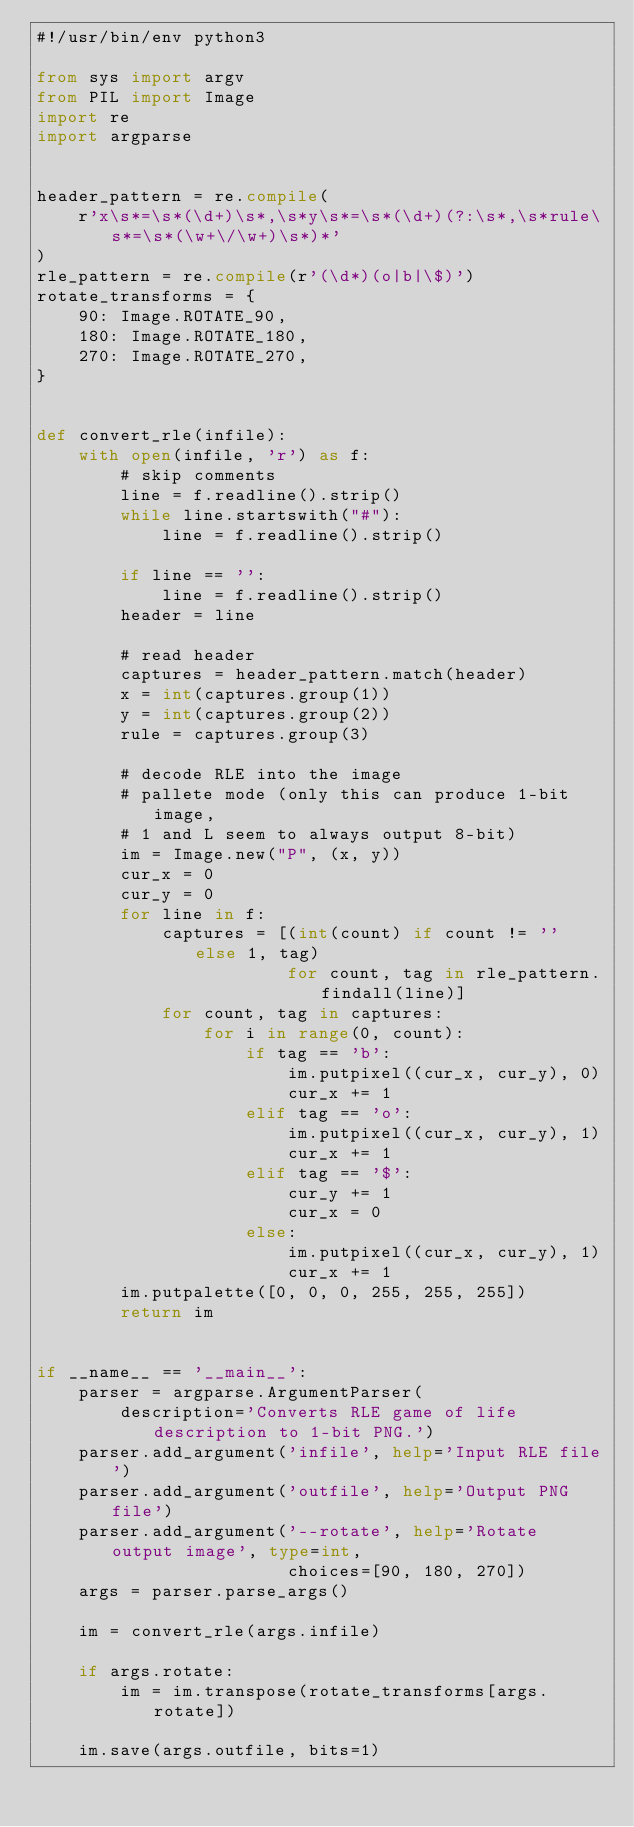<code> <loc_0><loc_0><loc_500><loc_500><_Python_>#!/usr/bin/env python3

from sys import argv
from PIL import Image
import re
import argparse


header_pattern = re.compile(
    r'x\s*=\s*(\d+)\s*,\s*y\s*=\s*(\d+)(?:\s*,\s*rule\s*=\s*(\w+\/\w+)\s*)*'
)
rle_pattern = re.compile(r'(\d*)(o|b|\$)')
rotate_transforms = {
    90: Image.ROTATE_90,
    180: Image.ROTATE_180,
    270: Image.ROTATE_270,
}


def convert_rle(infile):
    with open(infile, 'r') as f:
        # skip comments
        line = f.readline().strip()
        while line.startswith("#"):
            line = f.readline().strip()

        if line == '':
            line = f.readline().strip()
        header = line

        # read header
        captures = header_pattern.match(header)
        x = int(captures.group(1))
        y = int(captures.group(2))
        rule = captures.group(3)

        # decode RLE into the image
        # pallete mode (only this can produce 1-bit image,
        # 1 and L seem to always output 8-bit)
        im = Image.new("P", (x, y))
        cur_x = 0
        cur_y = 0
        for line in f:
            captures = [(int(count) if count != '' else 1, tag)
                        for count, tag in rle_pattern.findall(line)]
            for count, tag in captures:
                for i in range(0, count):
                    if tag == 'b':
                        im.putpixel((cur_x, cur_y), 0)
                        cur_x += 1
                    elif tag == 'o':
                        im.putpixel((cur_x, cur_y), 1)
                        cur_x += 1
                    elif tag == '$':
                        cur_y += 1
                        cur_x = 0
                    else:
                        im.putpixel((cur_x, cur_y), 1)
                        cur_x += 1
        im.putpalette([0, 0, 0, 255, 255, 255])
        return im


if __name__ == '__main__':
    parser = argparse.ArgumentParser(
        description='Converts RLE game of life description to 1-bit PNG.')
    parser.add_argument('infile', help='Input RLE file')
    parser.add_argument('outfile', help='Output PNG file')
    parser.add_argument('--rotate', help='Rotate output image', type=int,
                        choices=[90, 180, 270])
    args = parser.parse_args()

    im = convert_rle(args.infile)

    if args.rotate:
        im = im.transpose(rotate_transforms[args.rotate])

    im.save(args.outfile, bits=1)
</code> 